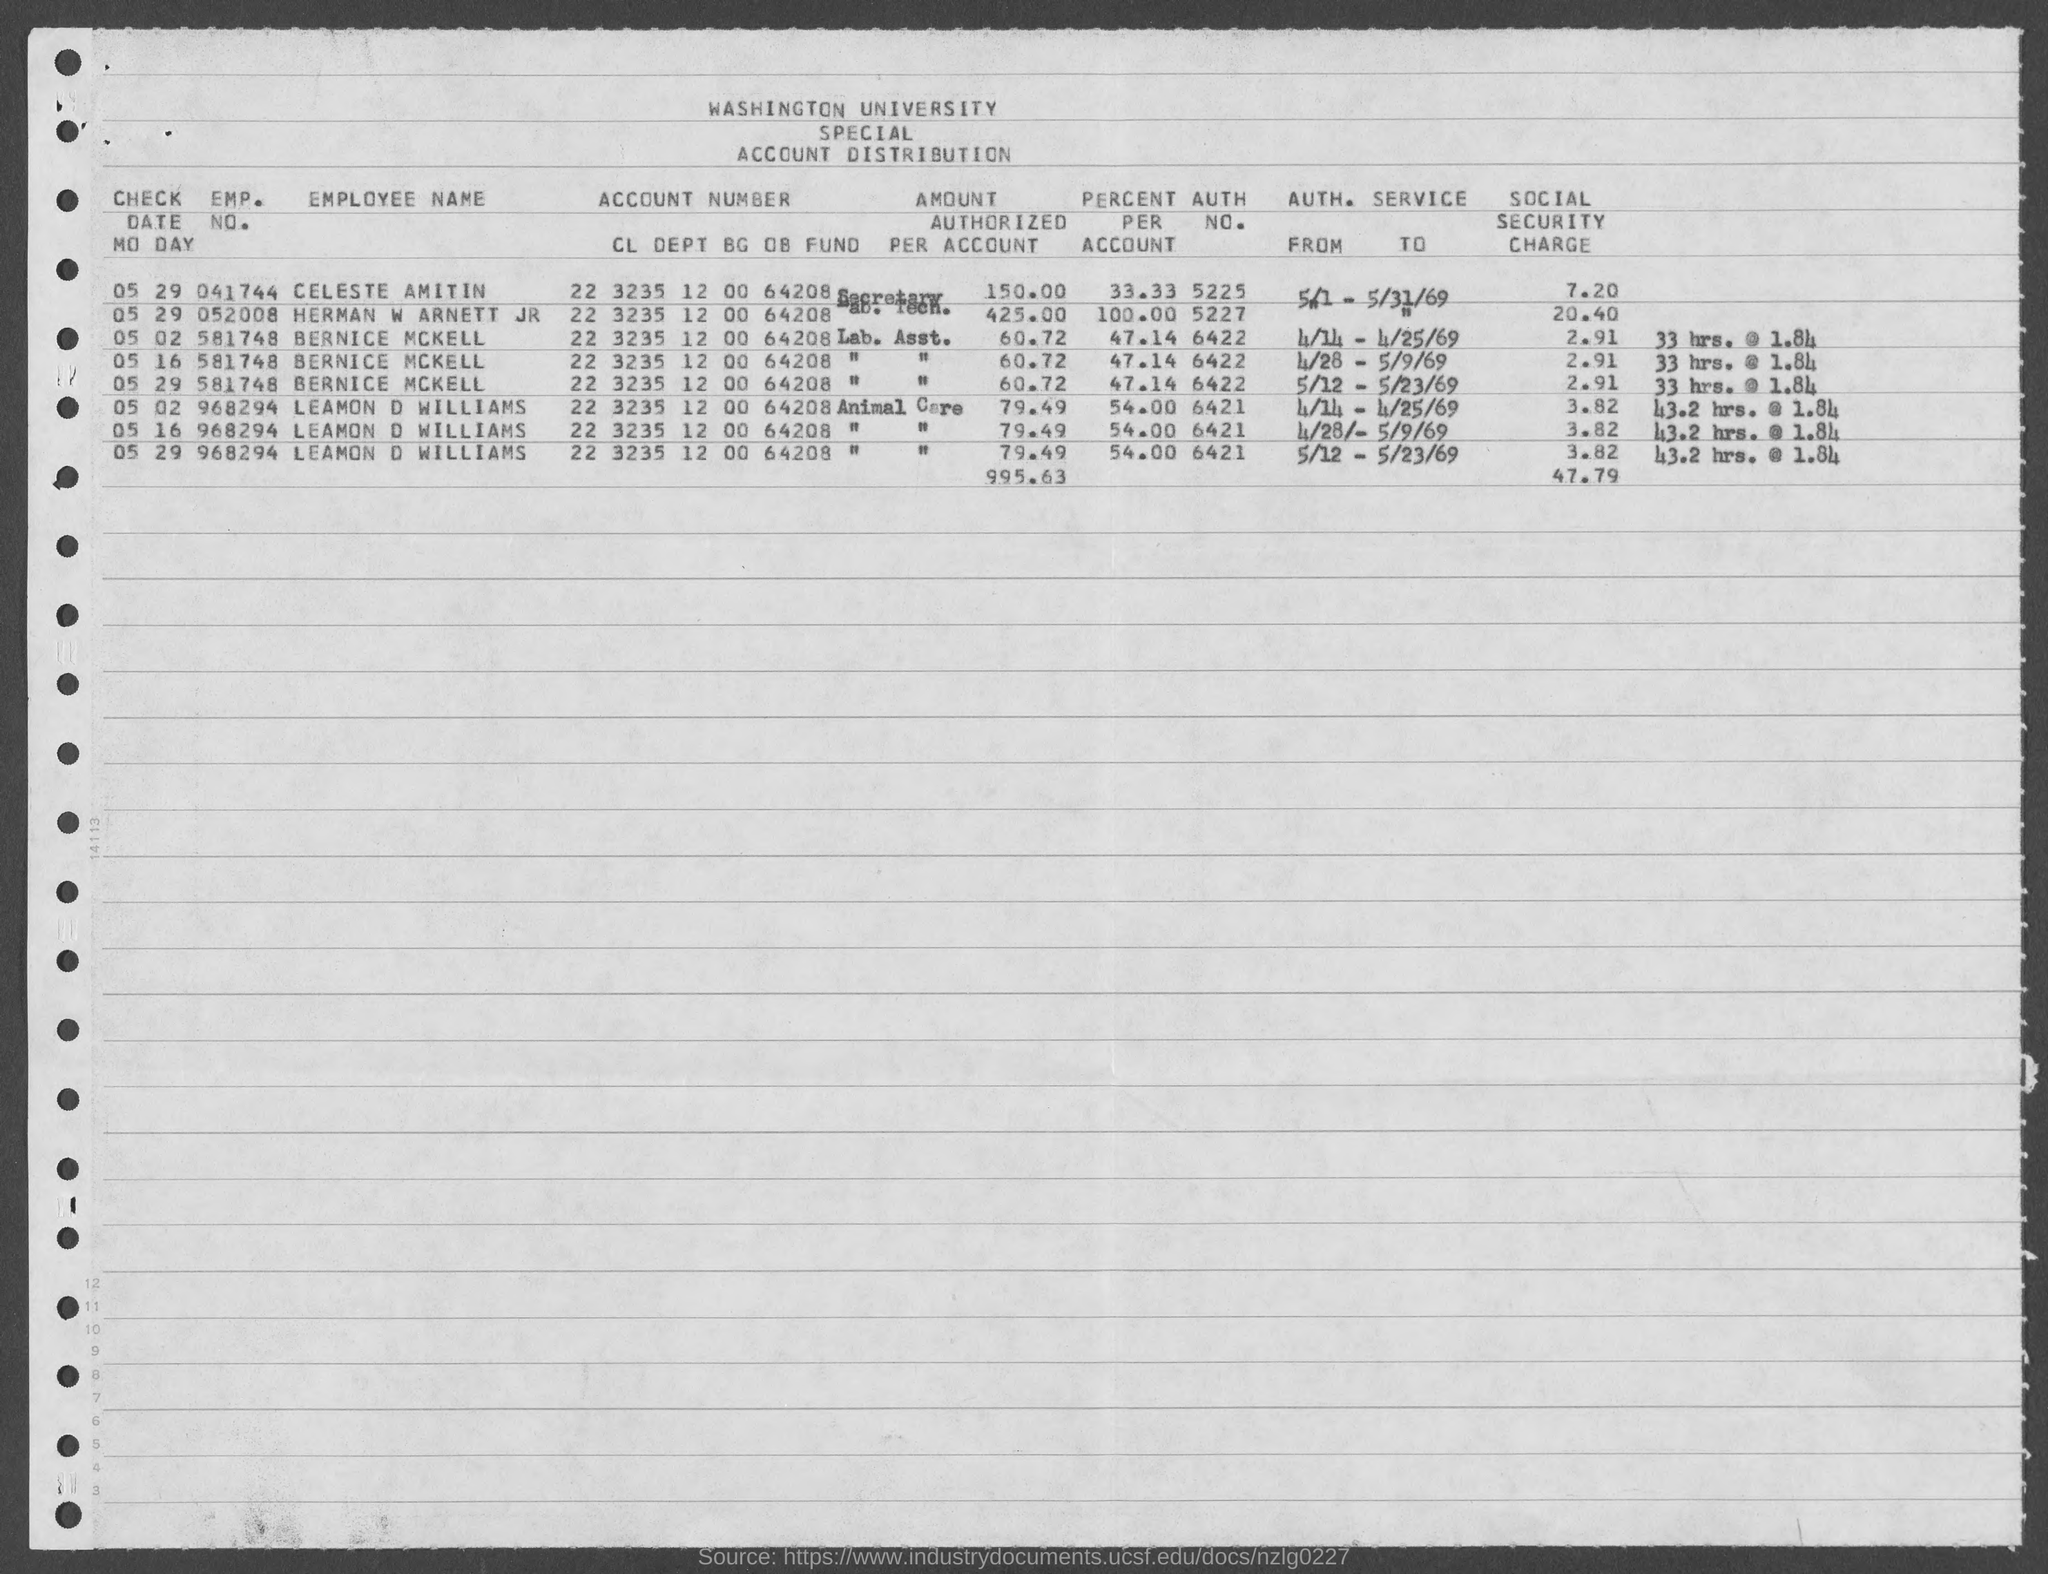Outline some significant characteristics in this image. The social security charge for Emp No. 052008 is 20.40 cents. The employee number of Bernice McKell is 581748. The percentage of Celeste Amitin is 33.33... percent. The author's name is Herman W Arnett JR, and the author's identification number is 5227. The account number of Celeste Amitin is 223235120064208. 